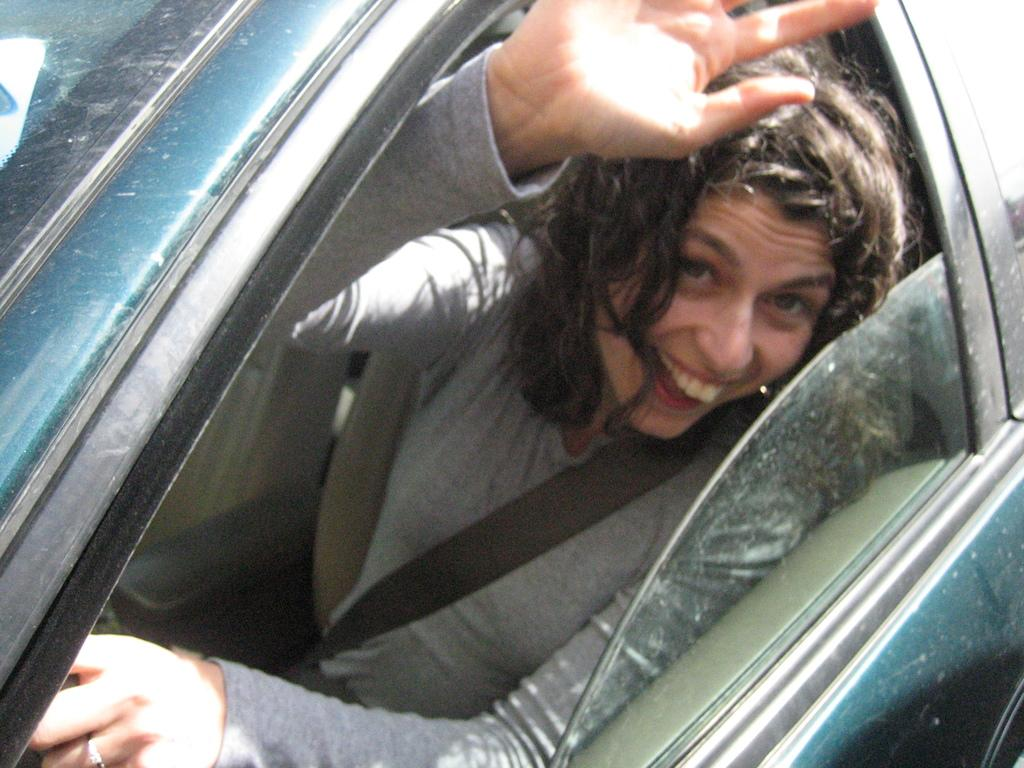Who is present in the image? There is a woman in the image. What is the woman doing in the image? The woman is sitting in a car. What color are the kittens playing on the playground in the image? There are no kittens or playground present in the image; it features a woman sitting in a car. 